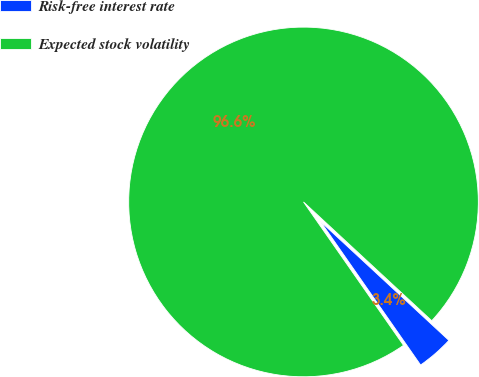Convert chart to OTSL. <chart><loc_0><loc_0><loc_500><loc_500><pie_chart><fcel>Risk-free interest rate<fcel>Expected stock volatility<nl><fcel>3.42%<fcel>96.58%<nl></chart> 